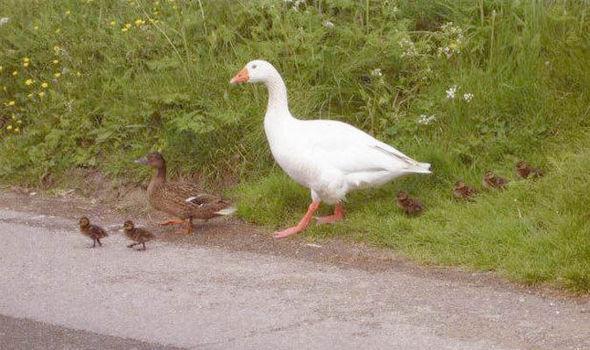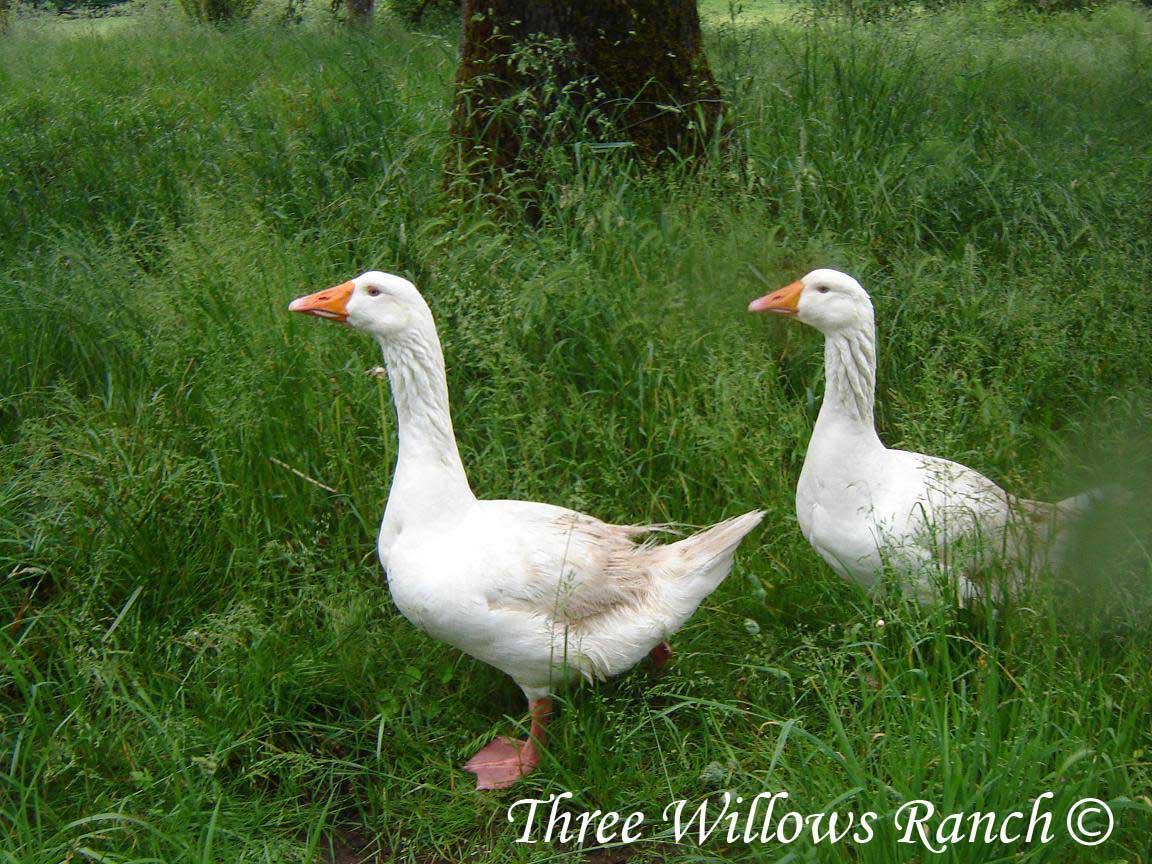The first image is the image on the left, the second image is the image on the right. Given the left and right images, does the statement "One image contains exactly three solid-white ducks, and the other image contains at least one solid-white duck." hold true? Answer yes or no. No. The first image is the image on the left, the second image is the image on the right. For the images displayed, is the sentence "The right image contains exactly two ducks walking on grass." factually correct? Answer yes or no. Yes. 